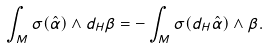<formula> <loc_0><loc_0><loc_500><loc_500>\int _ { M } \sigma ( \hat { \alpha } ) \wedge d _ { H } \beta = - \int _ { M } \sigma ( d _ { H } \hat { \alpha } ) \wedge \beta .</formula> 